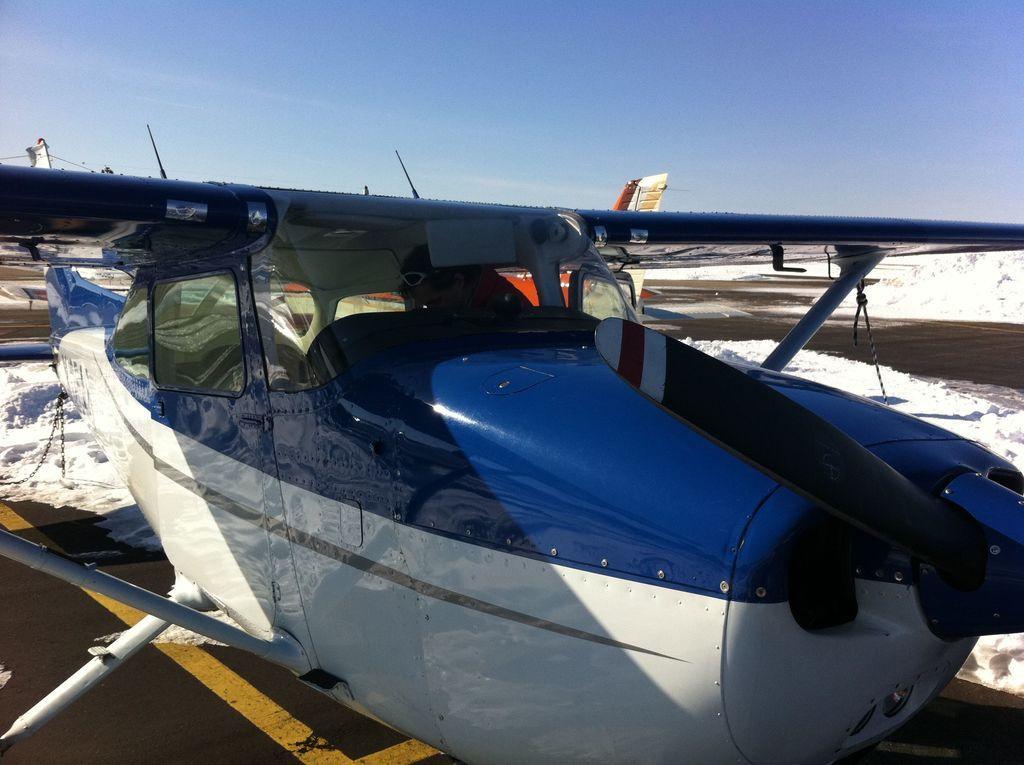In one or two sentences, can you explain what this image depicts? In the image we can see the flying jet. In the flying jet we can see a person wearing goggles. Here we can see the road, snow and the sky. 